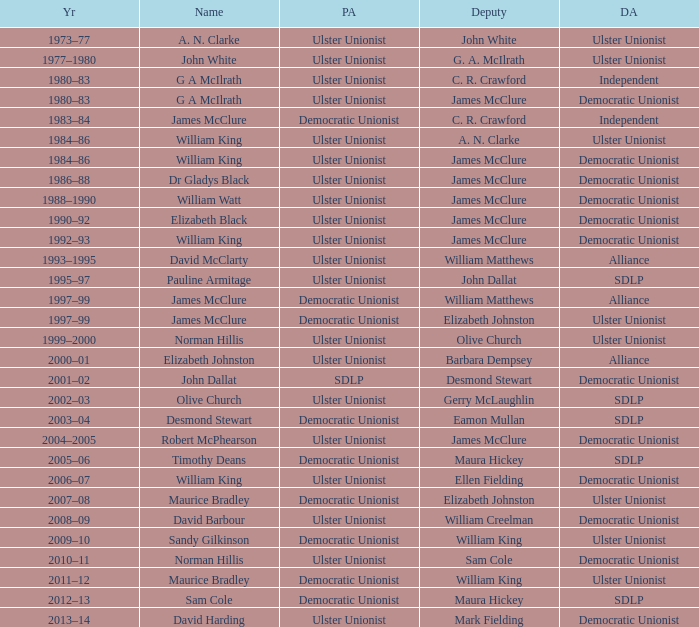What Year was james mcclure Deputy, and the Name is robert mcphearson? 2004–2005. 